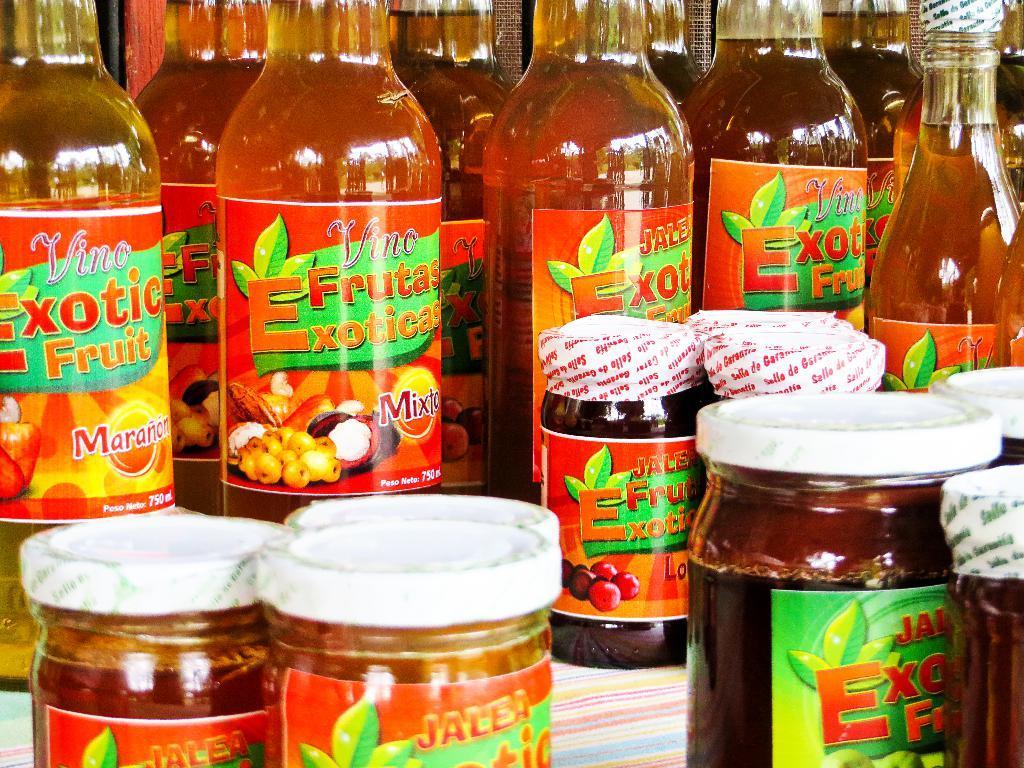Describe this image in one or two sentences. In this image we can see the fruit exotic bottles and also the jars placed on some cloth. 